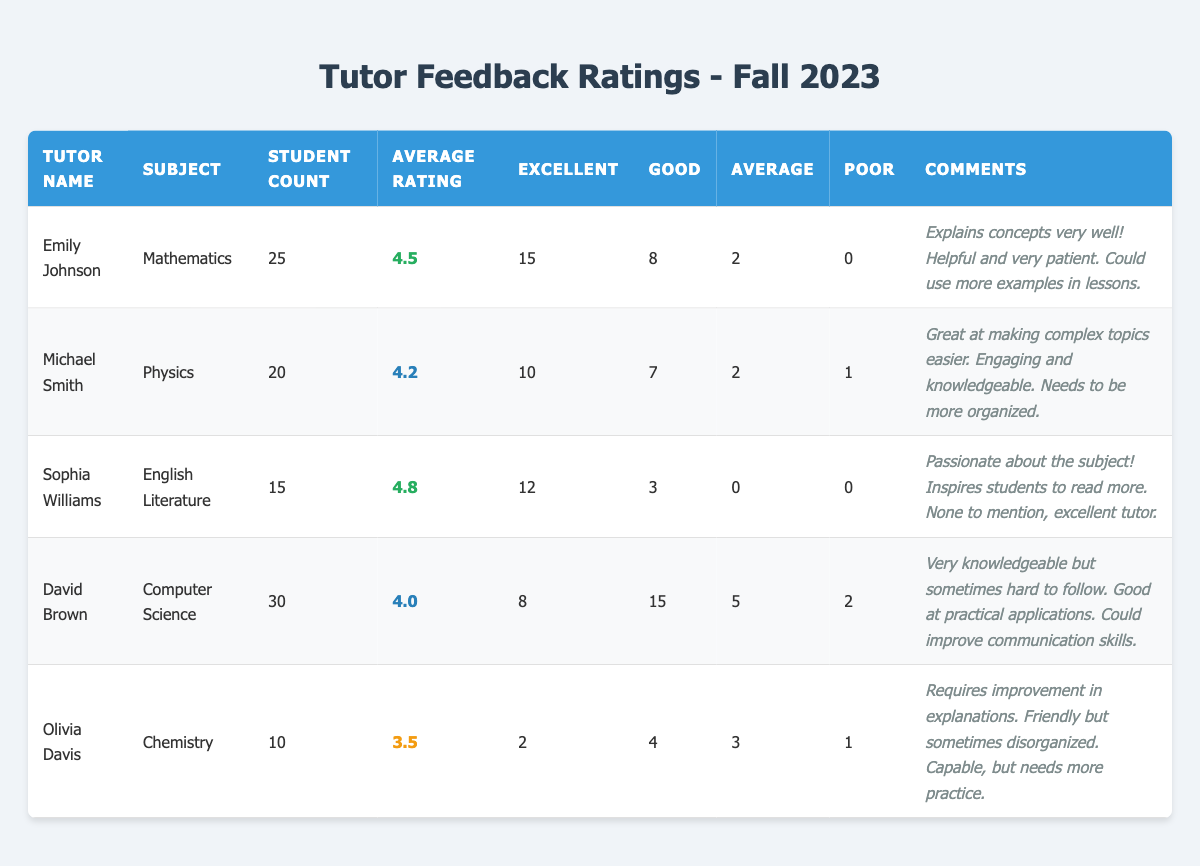What is the average rating for Sophia Williams? To find the average rating for Sophia Williams, we look directly at her entry in the table, where the average rating is listed as 4.8.
Answer: 4.8 Which tutor has the highest student count? By comparing the student counts across all tutors in the table, we find that David Brown has the highest count with 30 students.
Answer: David Brown How many students rated Olivia Davis as excellent? In the feedback for Olivia Davis, it shows that 2 students rated her as excellent.
Answer: 2 What is the overall average rating of all tutors combined? To find this, we sum the average ratings of all tutors: (4.5 + 4.2 + 4.8 + 4.0 + 3.5) = 20.0. Then, we divide by the number of tutors (5): 20.0 / 5 = 4.0.
Answer: 4.0 Did any tutor receive no ratings of poor? Checking the ratings of each tutor, we see that both Emily Johnson and Sophia Williams received 0 ratings of poor. Therefore, the answer is yes.
Answer: Yes Who has the lowest average rating among the tutors? Comparing the average ratings, the lowest average rating is for Olivia Davis at 3.5.
Answer: Olivia Davis How many more students rated Michael Smith as excellent than as poor? Michael Smith received 10 ratings of excellent and 1 rating of poor. The difference is 10 - 1 = 9.
Answer: 9 Which subject received the highest average rating? Analyzing the average ratings by subject, Sophia Williams (English Literature) has the highest average rating at 4.8.
Answer: English Literature What is the total number of excellent ratings across all tutors? Adding the excellent ratings for all tutors: 15 (Emily) + 10 (Michael) + 12 (Sophia) + 8 (David) + 2 (Olivia) = 47.
Answer: 47 Is the average rating of David Brown higher than 4.0? David Brown's average rating is exactly 4.0, so it is not higher than 4.0.
Answer: No 